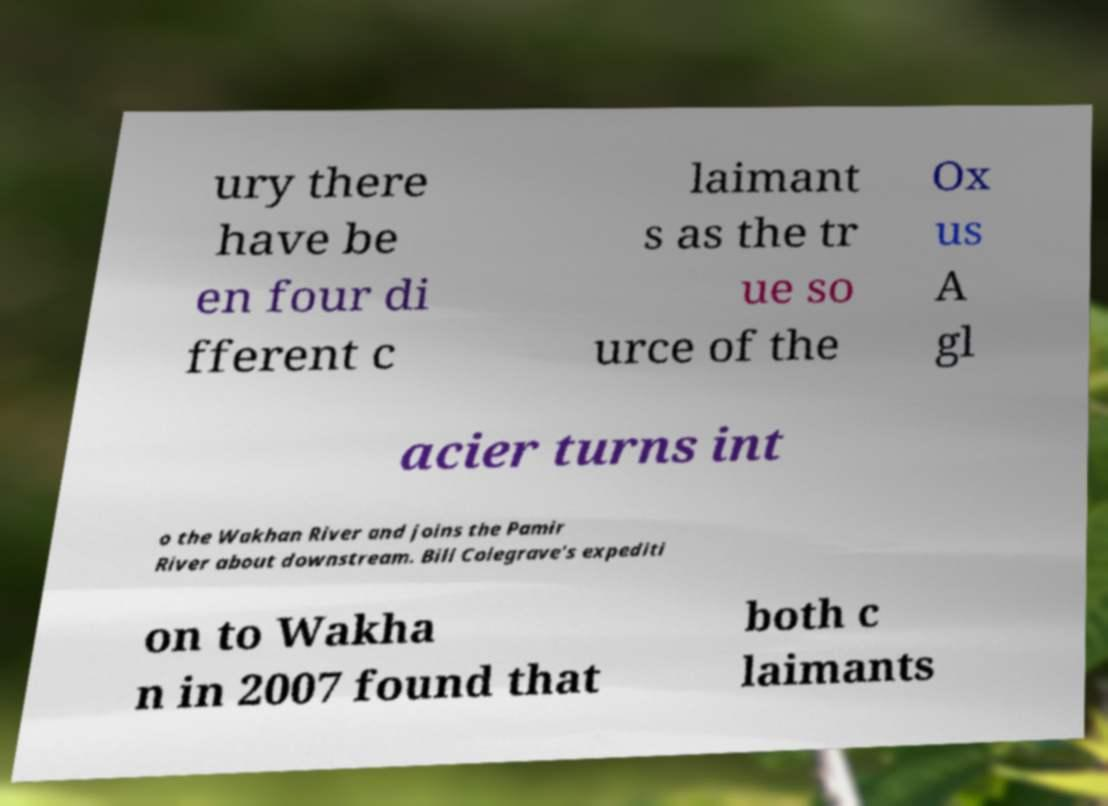What messages or text are displayed in this image? I need them in a readable, typed format. ury there have be en four di fferent c laimant s as the tr ue so urce of the Ox us A gl acier turns int o the Wakhan River and joins the Pamir River about downstream. Bill Colegrave's expediti on to Wakha n in 2007 found that both c laimants 